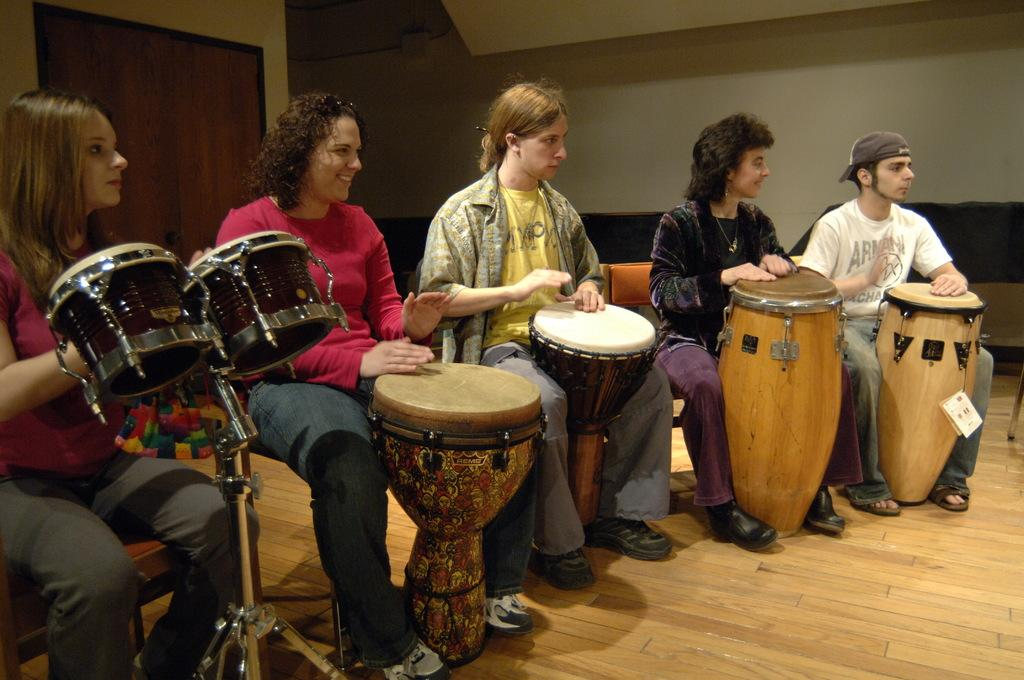How many people are present in the image? There are five people in the image. What are the people doing in the image? The people are sitting on chairs and playing different kinds of drums. Can you describe the background of the image? There is a wall in the background of the image, and to the left, there is a door. How many clovers can be seen on the ground in the image? There are no clovers present in the image; it features a group of people playing drums. 